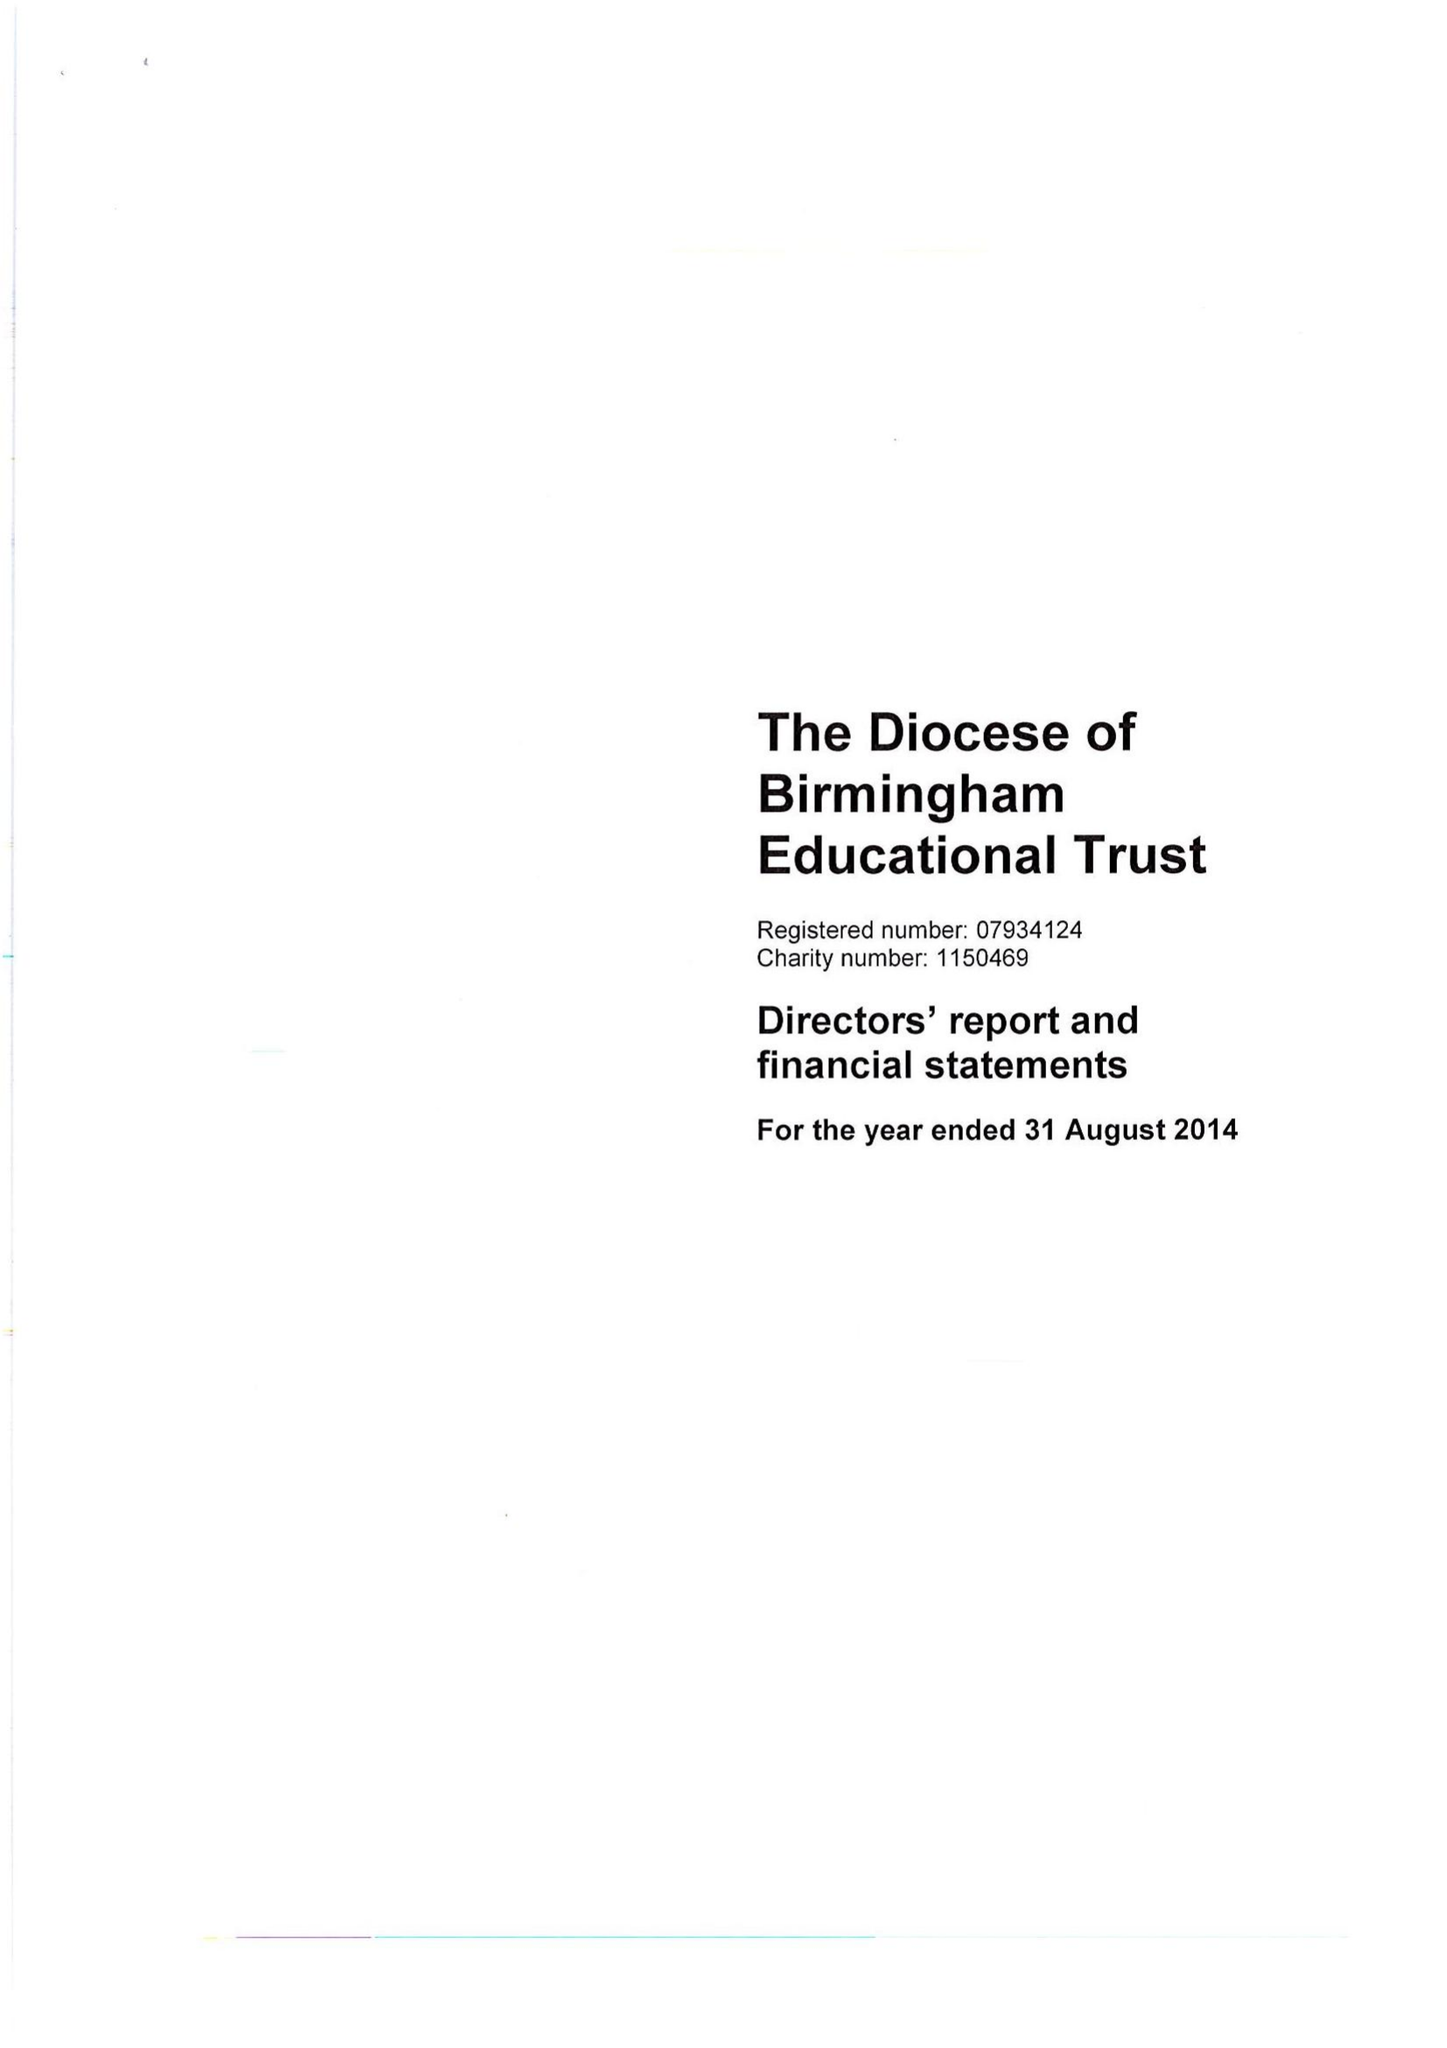What is the value for the charity_name?
Answer the question using a single word or phrase. The Diocese Of Birmingham Educational Trust 